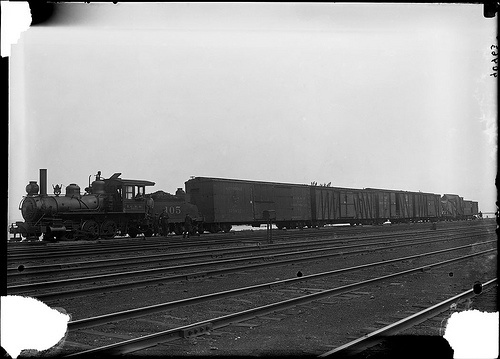Describe the objects in this image and their specific colors. I can see a train in black, gray, darkgray, and lightgray tones in this image. 